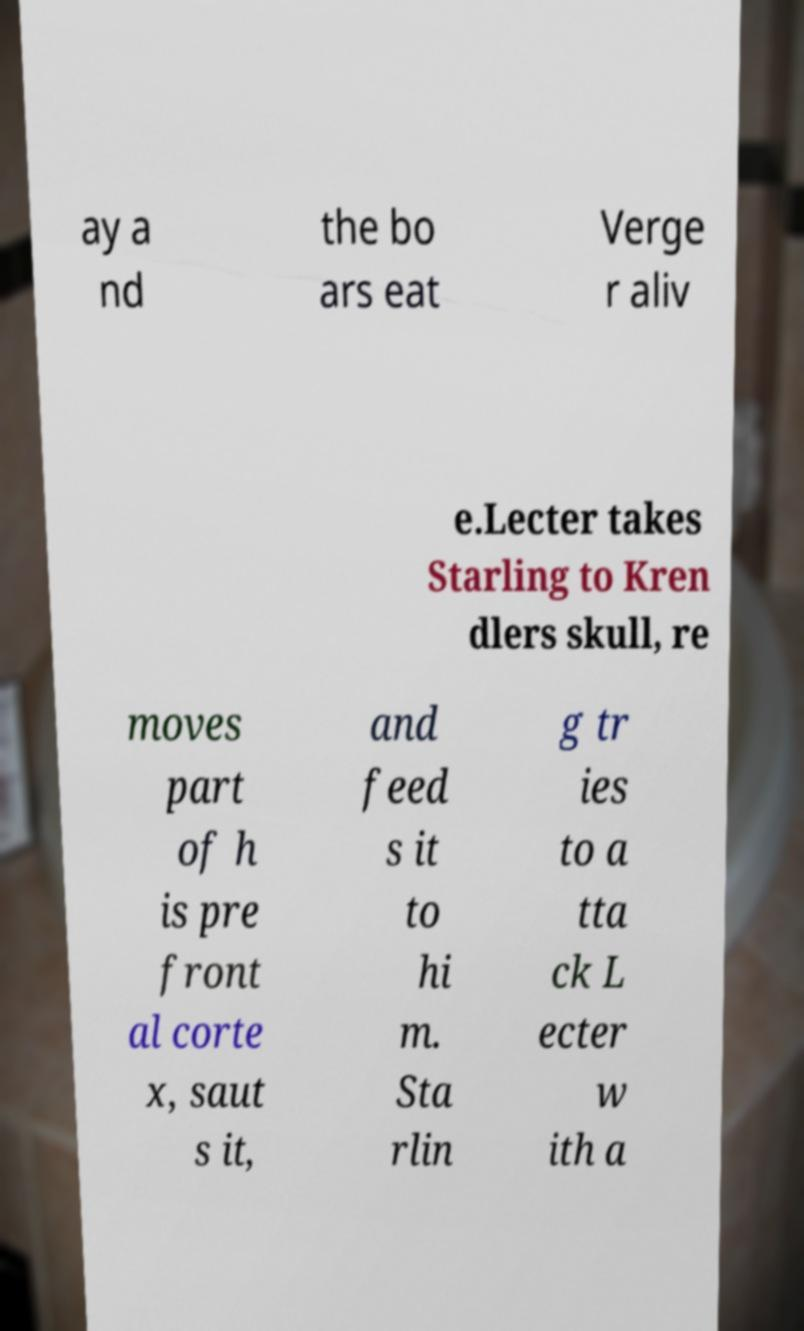There's text embedded in this image that I need extracted. Can you transcribe it verbatim? ay a nd the bo ars eat Verge r aliv e.Lecter takes Starling to Kren dlers skull, re moves part of h is pre front al corte x, saut s it, and feed s it to hi m. Sta rlin g tr ies to a tta ck L ecter w ith a 